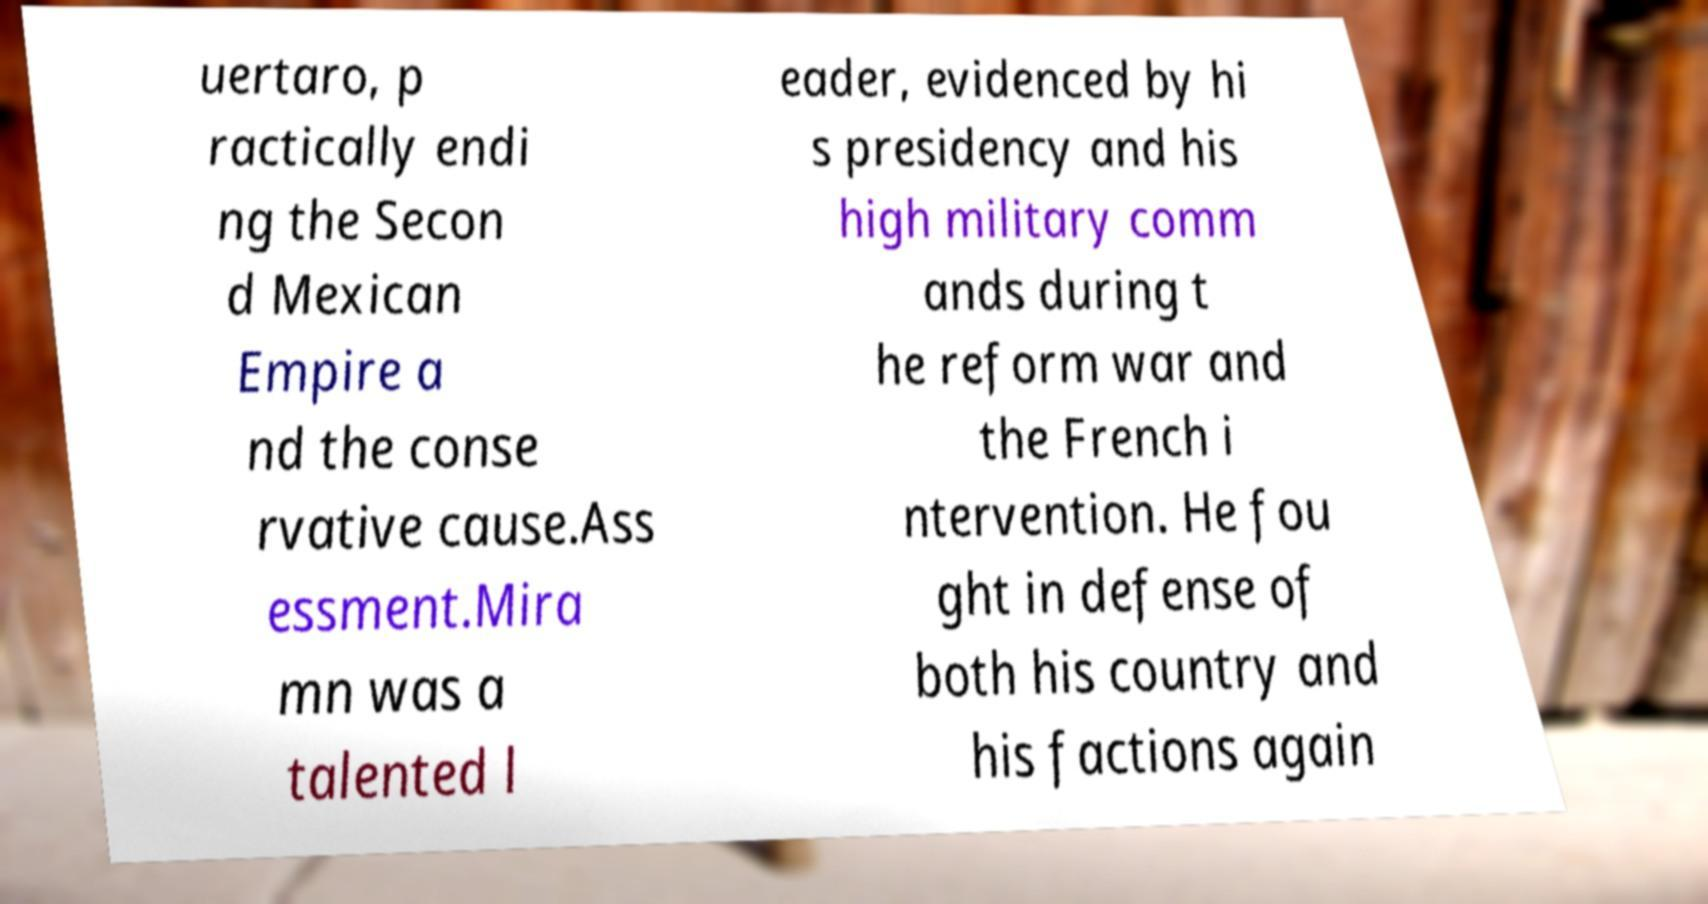Can you read and provide the text displayed in the image?This photo seems to have some interesting text. Can you extract and type it out for me? uertaro, p ractically endi ng the Secon d Mexican Empire a nd the conse rvative cause.Ass essment.Mira mn was a talented l eader, evidenced by hi s presidency and his high military comm ands during t he reform war and the French i ntervention. He fou ght in defense of both his country and his factions again 